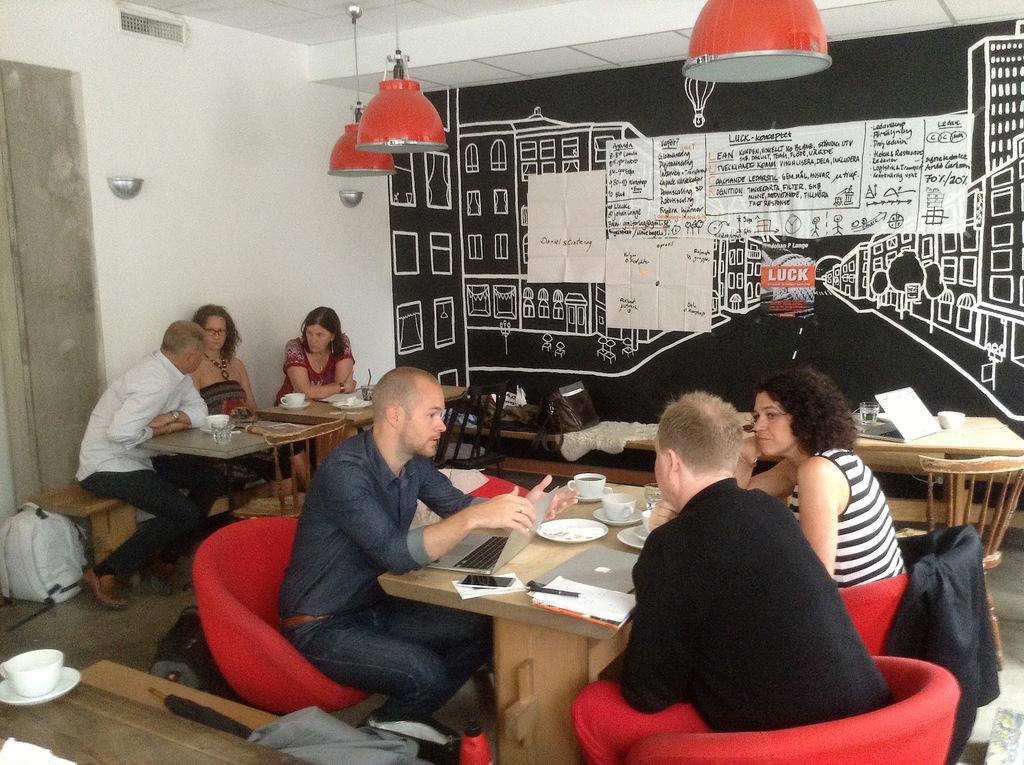Can you describe this image briefly? In this Image I see number of people who are sitting on chairs and there are tables and there are few things on it. In the background I see the wall, papers and the lights. 